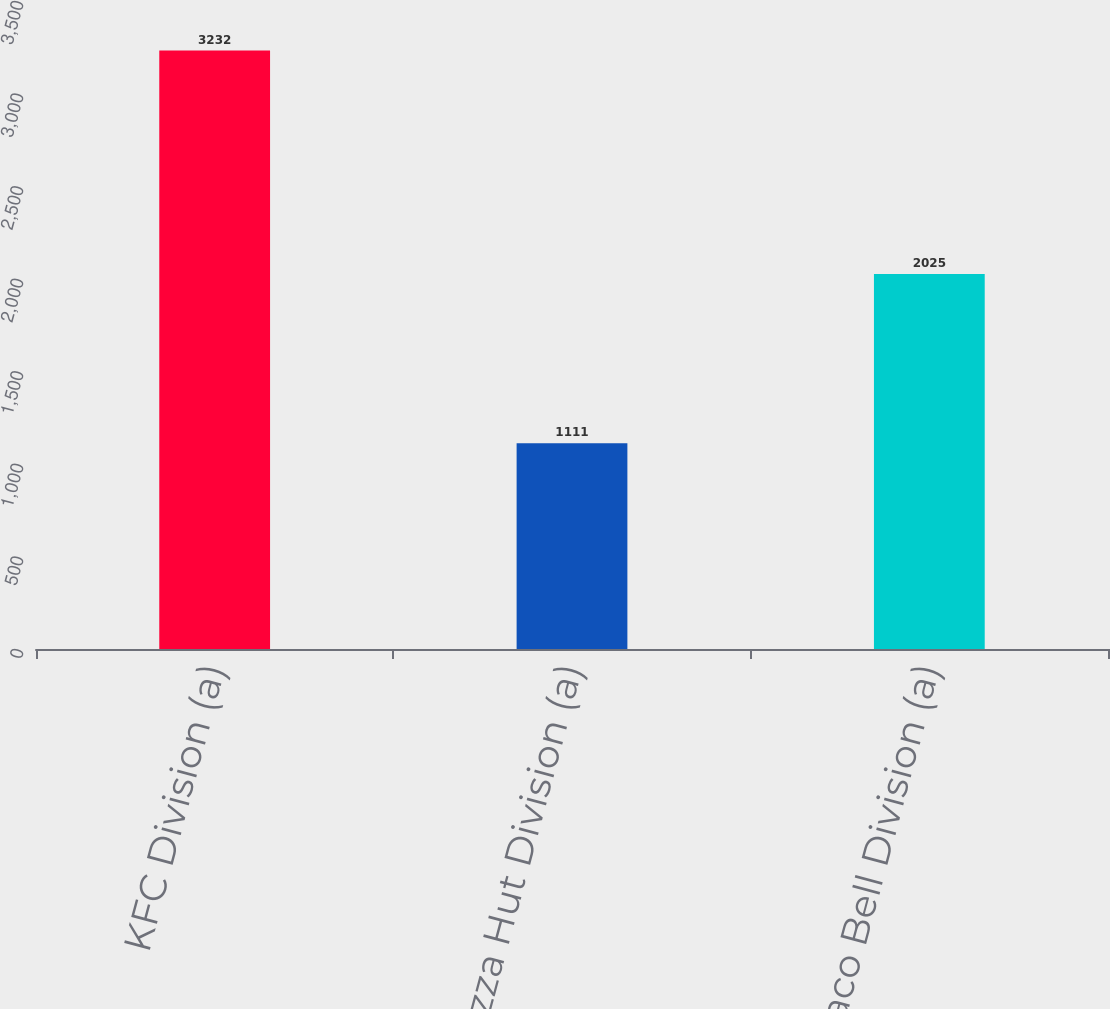Convert chart to OTSL. <chart><loc_0><loc_0><loc_500><loc_500><bar_chart><fcel>KFC Division (a)<fcel>Pizza Hut Division (a)<fcel>Taco Bell Division (a)<nl><fcel>3232<fcel>1111<fcel>2025<nl></chart> 